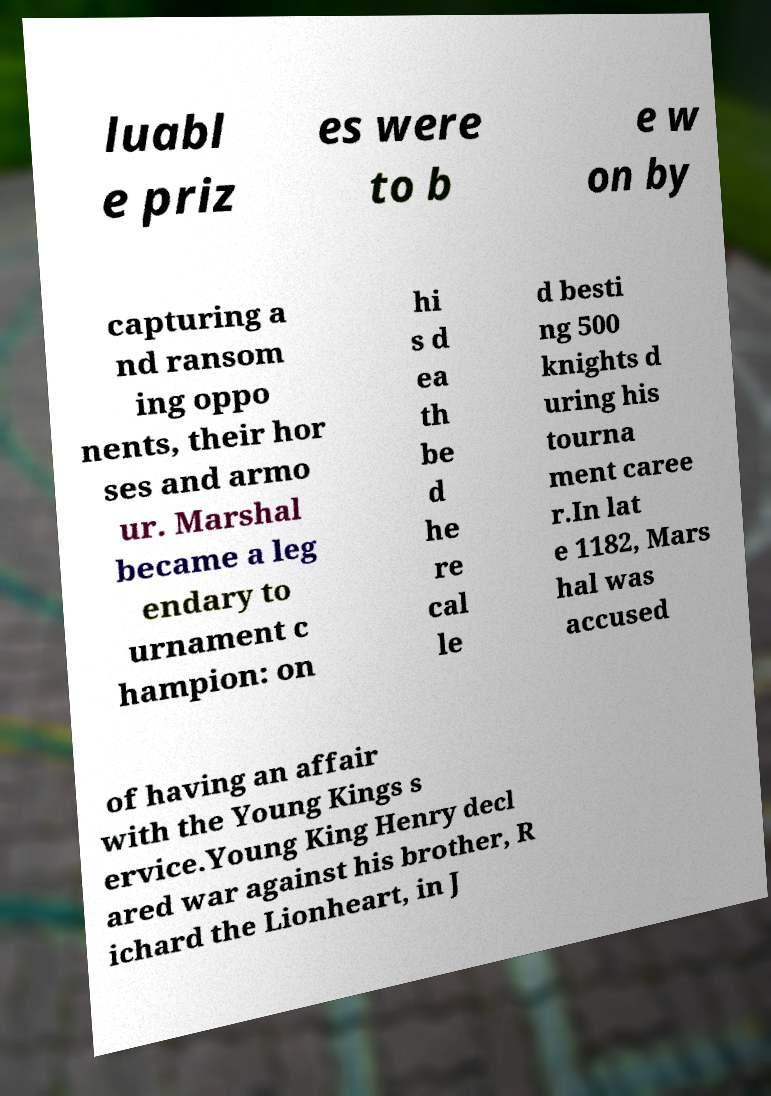What messages or text are displayed in this image? I need them in a readable, typed format. luabl e priz es were to b e w on by capturing a nd ransom ing oppo nents, their hor ses and armo ur. Marshal became a leg endary to urnament c hampion: on hi s d ea th be d he re cal le d besti ng 500 knights d uring his tourna ment caree r.In lat e 1182, Mars hal was accused of having an affair with the Young Kings s ervice.Young King Henry decl ared war against his brother, R ichard the Lionheart, in J 